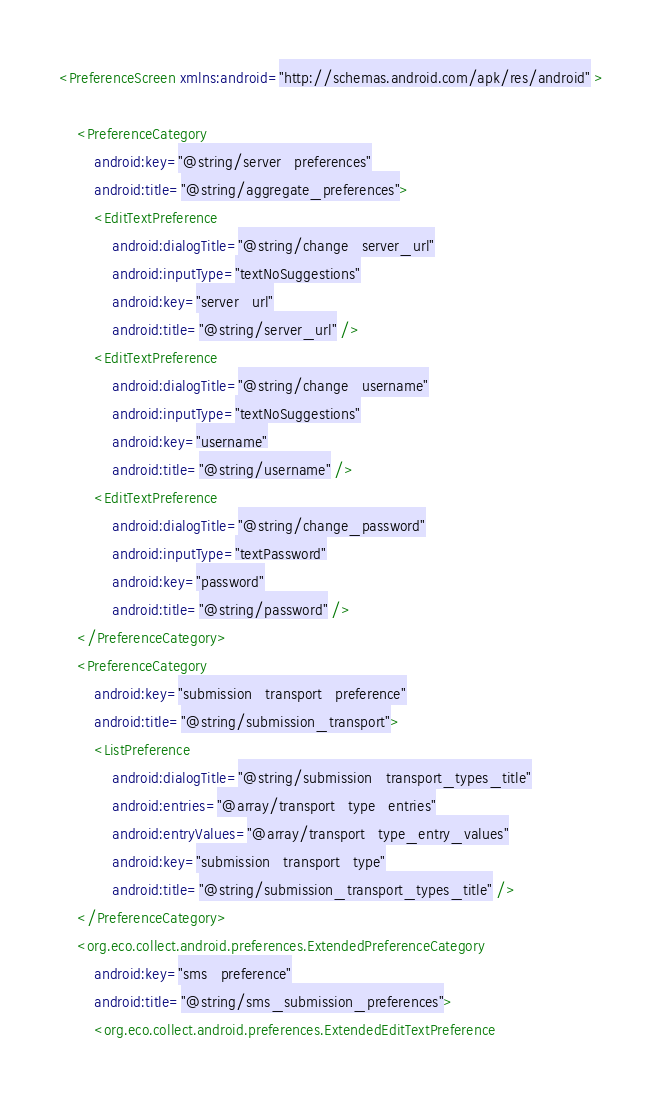Convert code to text. <code><loc_0><loc_0><loc_500><loc_500><_XML_><PreferenceScreen xmlns:android="http://schemas.android.com/apk/res/android" >

    <PreferenceCategory
        android:key="@string/server_preferences"
        android:title="@string/aggregate_preferences">
        <EditTextPreference
            android:dialogTitle="@string/change_server_url"
            android:inputType="textNoSuggestions"
            android:key="server_url"
            android:title="@string/server_url" />
        <EditTextPreference
            android:dialogTitle="@string/change_username"
            android:inputType="textNoSuggestions"
            android:key="username"
            android:title="@string/username" />
        <EditTextPreference
            android:dialogTitle="@string/change_password"
            android:inputType="textPassword"
            android:key="password"
            android:title="@string/password" />
    </PreferenceCategory>
    <PreferenceCategory
        android:key="submission_transport_preference"
        android:title="@string/submission_transport">
        <ListPreference
            android:dialogTitle="@string/submission_transport_types_title"
            android:entries="@array/transport_type_entries"
            android:entryValues="@array/transport_type_entry_values"
            android:key="submission_transport_type"
            android:title="@string/submission_transport_types_title" />
    </PreferenceCategory>
    <org.eco.collect.android.preferences.ExtendedPreferenceCategory
        android:key="sms_preference"
        android:title="@string/sms_submission_preferences">
        <org.eco.collect.android.preferences.ExtendedEditTextPreference</code> 